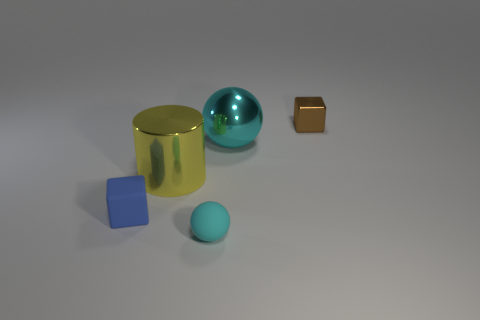There is a small matte thing right of the shiny cylinder in front of the cyan metallic sphere; what is its color?
Make the answer very short. Cyan. What number of metal objects are brown blocks or cylinders?
Provide a short and direct response. 2. Is the large cyan sphere made of the same material as the blue object?
Offer a terse response. No. The tiny thing on the right side of the cyan object that is in front of the blue object is made of what material?
Your answer should be very brief. Metal. What number of big things are either blue objects or cyan matte balls?
Your response must be concise. 0. What is the size of the metallic cylinder?
Make the answer very short. Large. Is the number of small blue blocks that are left of the big cyan metal thing greater than the number of blue metallic cylinders?
Your response must be concise. Yes. Are there an equal number of brown shiny things to the left of the tiny brown metallic block and metal cubes to the left of the rubber ball?
Keep it short and to the point. Yes. What color is the thing that is both in front of the small brown shiny cube and behind the big yellow cylinder?
Your answer should be compact. Cyan. Are there more metallic spheres that are in front of the brown object than cyan balls to the left of the blue thing?
Keep it short and to the point. Yes. 